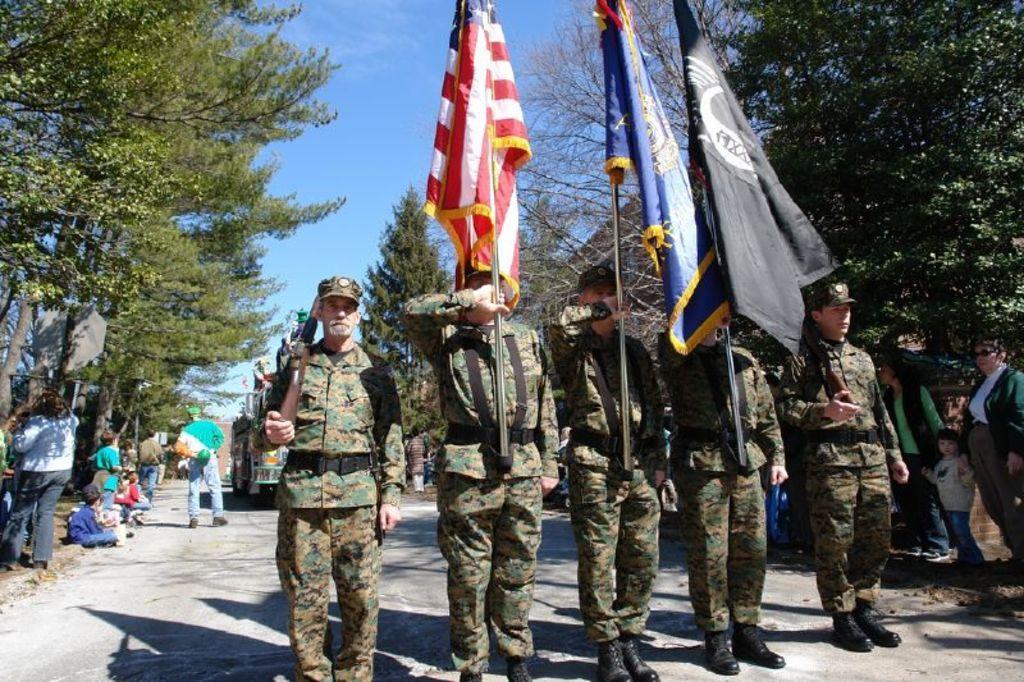In one or two sentences, can you explain what this image depicts? In this picture I can see five persons standing, there are two persons holding rifles and three persons holding flags, there are group of people standing, there is a vehicle on the road, there are trees, and in the background there is the sky. 